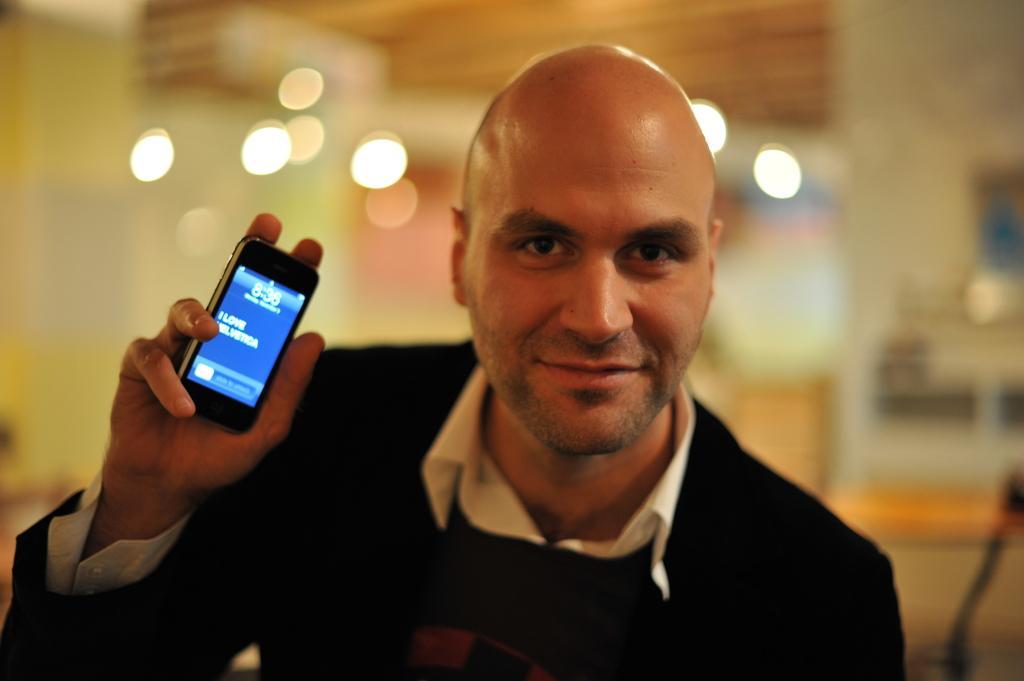Please provide a concise description of this image. There is a man holding a mobile phone in his hand. 